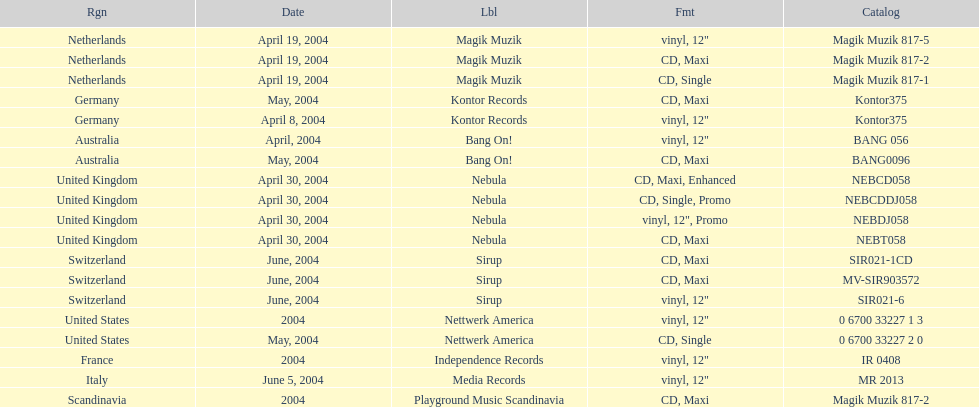What label was the only label to be used by france? Independence Records. 